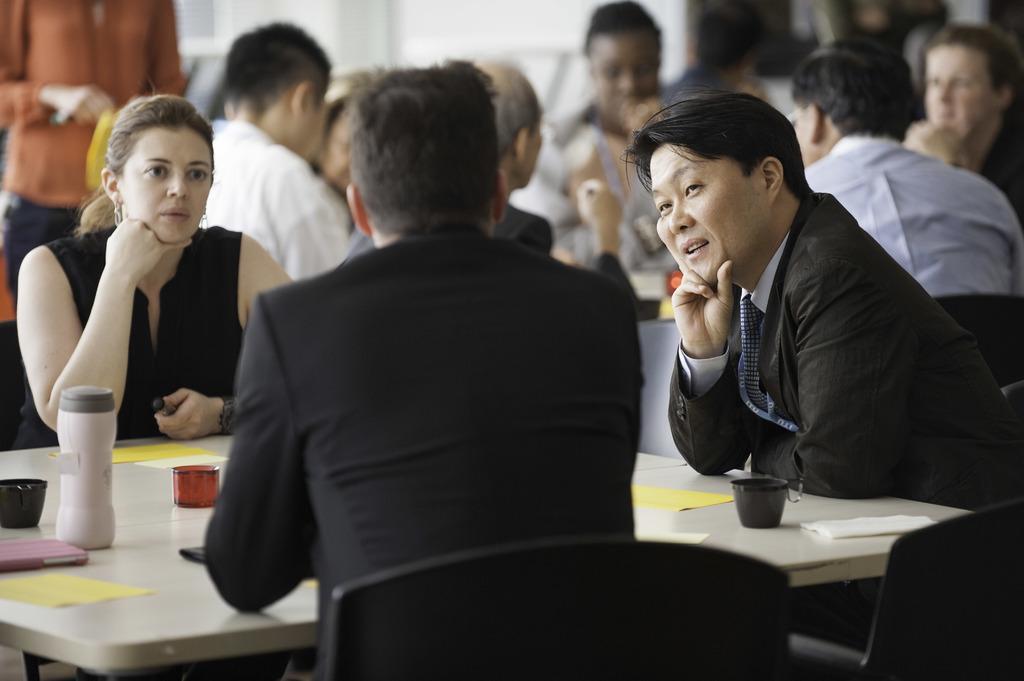How would you summarize this image in a sentence or two? Two men and a woman sitting around the table in the front. There is a bottle and coffee mug and phone and papers and tissue on the table. On the background there are bunch of men sitting around the table. There is a person stood behind the women. The three people in the wearing black dresses. 